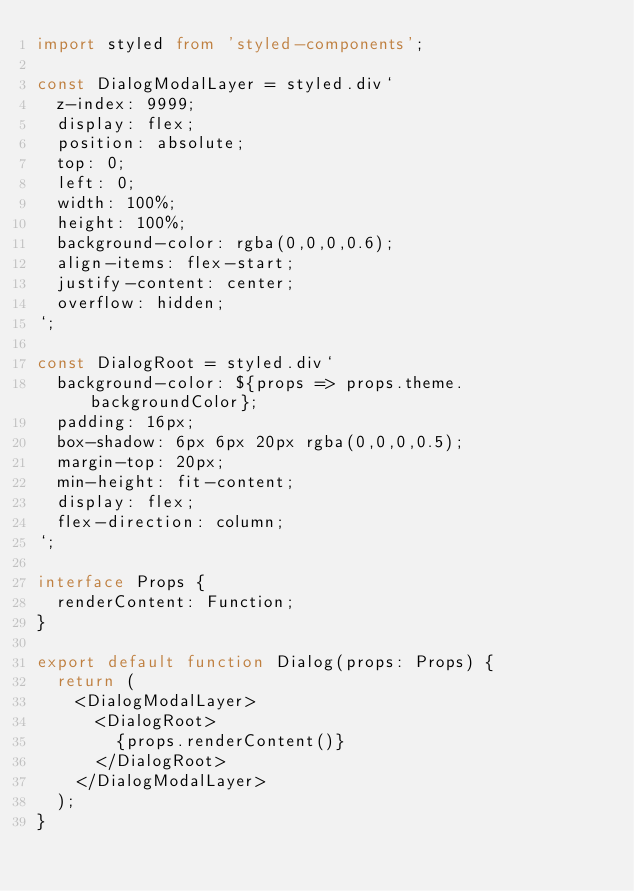<code> <loc_0><loc_0><loc_500><loc_500><_TypeScript_>import styled from 'styled-components';

const DialogModalLayer = styled.div`
	z-index: 9999;
	display: flex;
	position: absolute;
	top: 0;
	left: 0;
	width: 100%;
	height: 100%;
	background-color: rgba(0,0,0,0.6);
	align-items: flex-start;
	justify-content: center;
	overflow: hidden;
`;

const DialogRoot = styled.div`
	background-color: ${props => props.theme.backgroundColor};
	padding: 16px;
	box-shadow: 6px 6px 20px rgba(0,0,0,0.5);
	margin-top: 20px;
	min-height: fit-content;
	display: flex;
	flex-direction: column;
`;

interface Props {
	renderContent: Function;
}

export default function Dialog(props: Props) {
	return (
		<DialogModalLayer>
			<DialogRoot>
				{props.renderContent()}
			</DialogRoot>
		</DialogModalLayer>
	);
}
</code> 